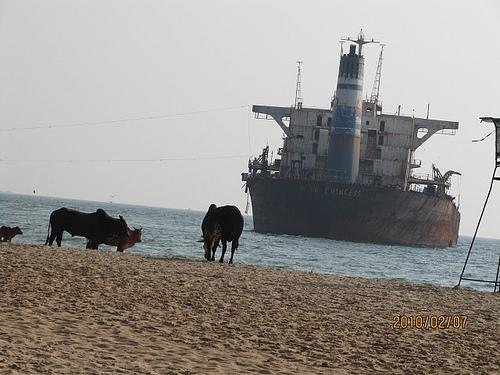How many cows are sniffing around on the beach front? four 